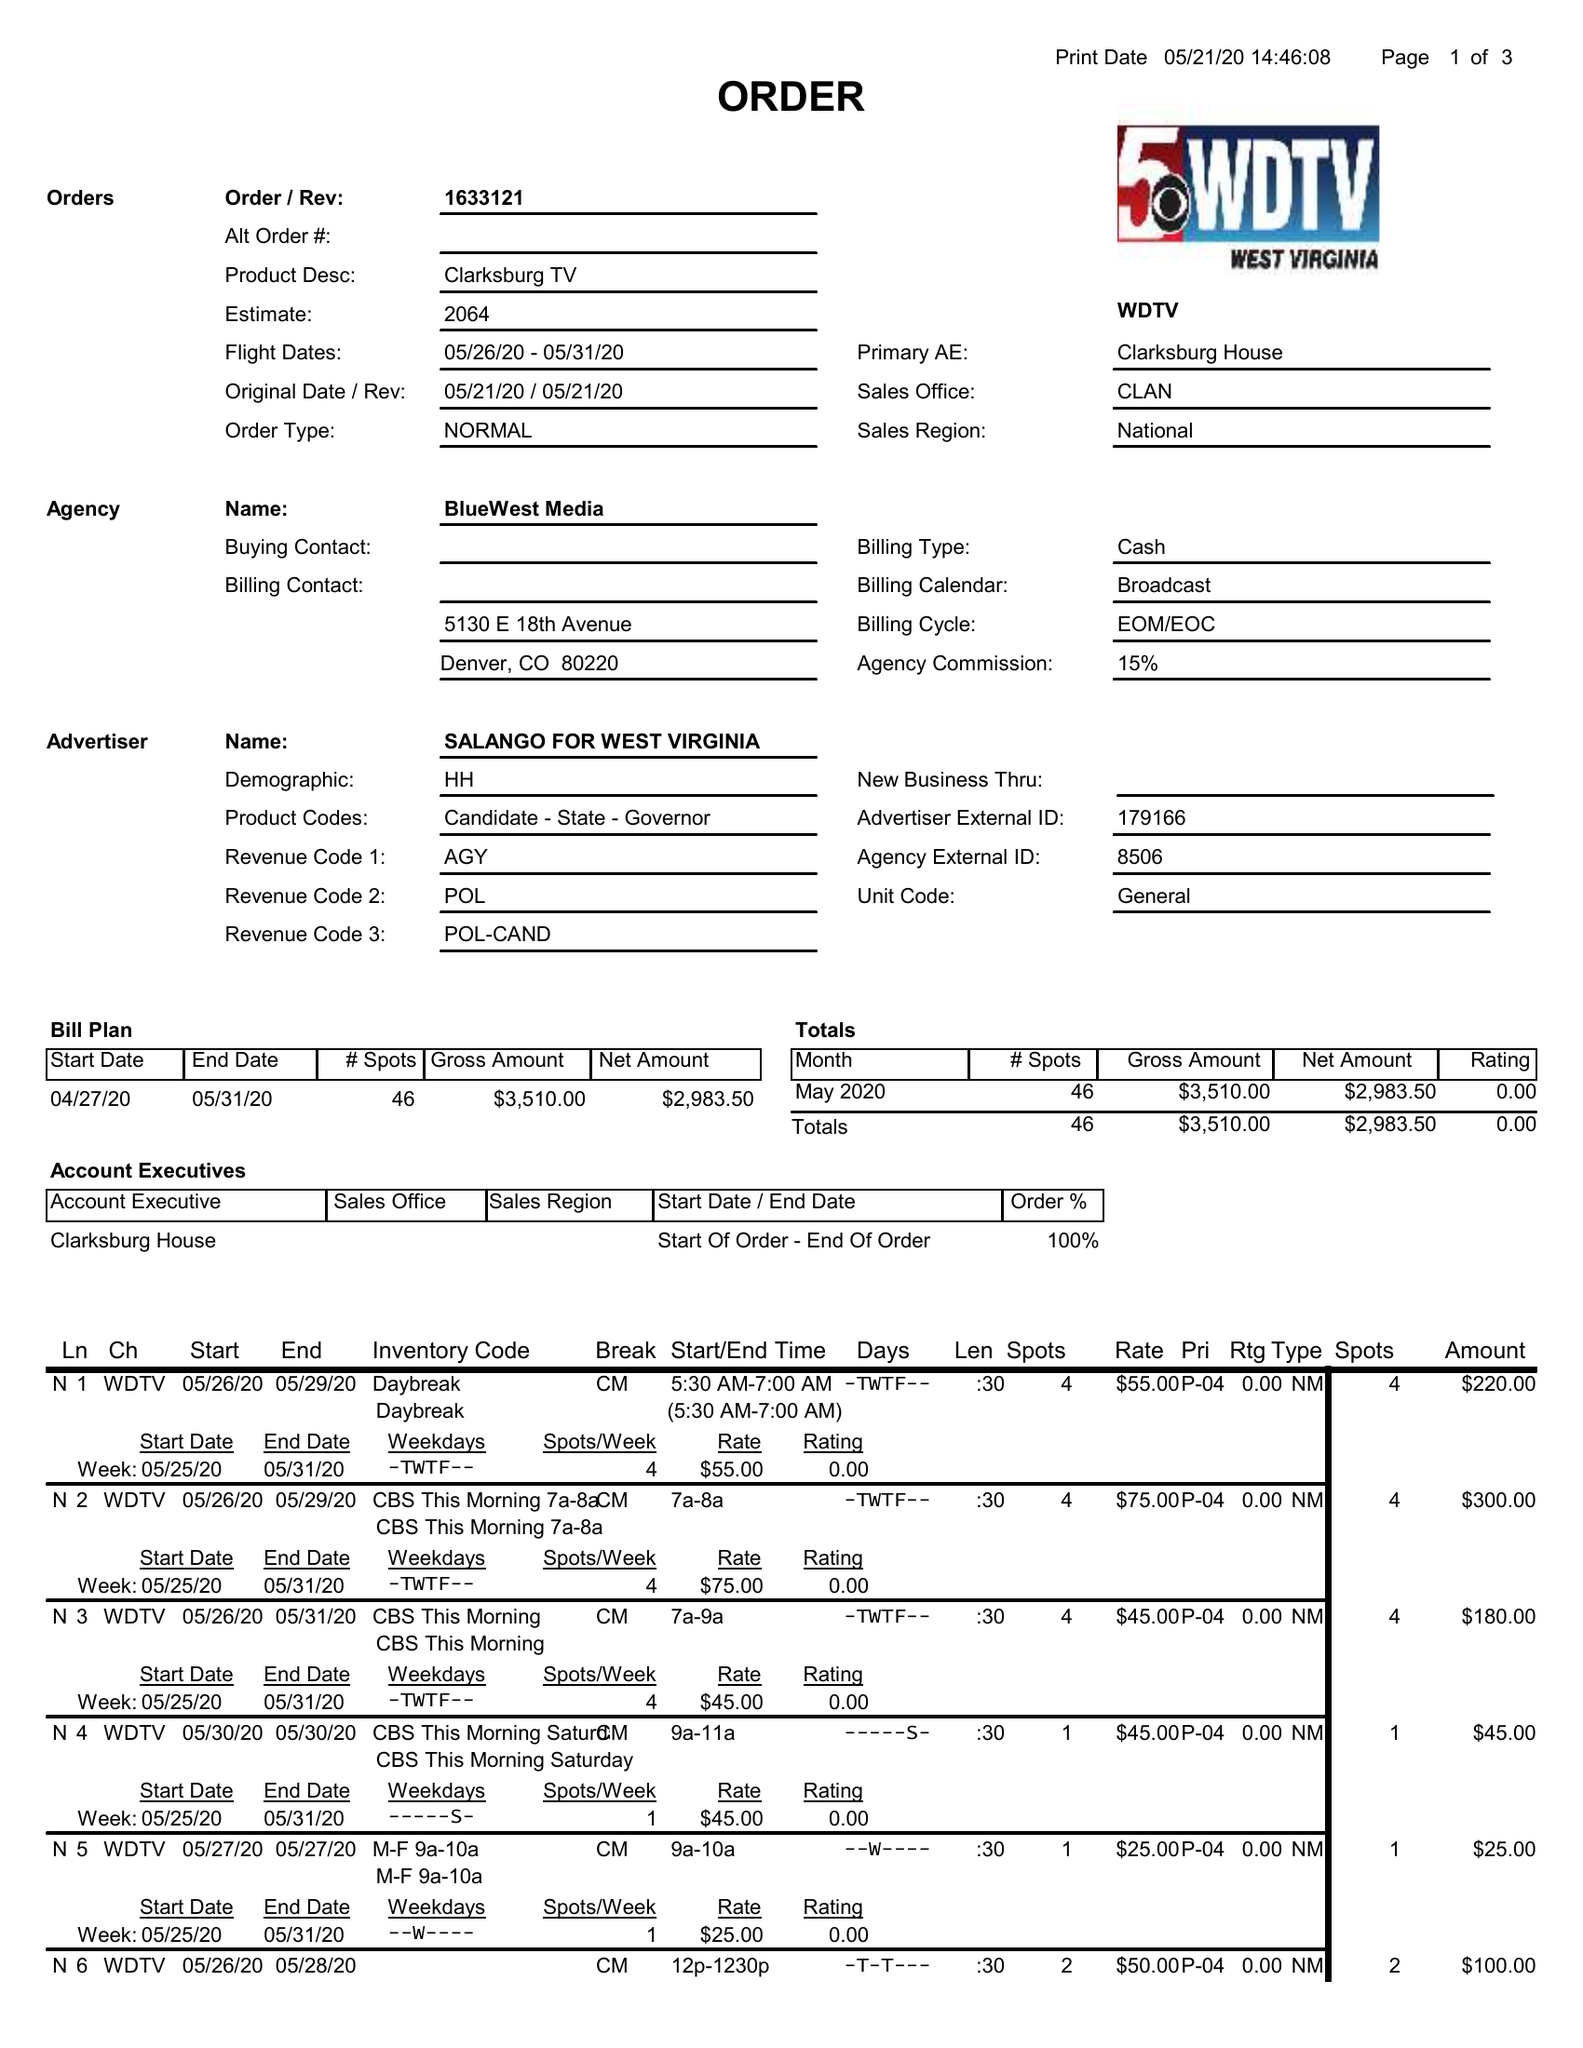What is the value for the advertiser?
Answer the question using a single word or phrase. SALANGO FOR WEST VIRGINIA 